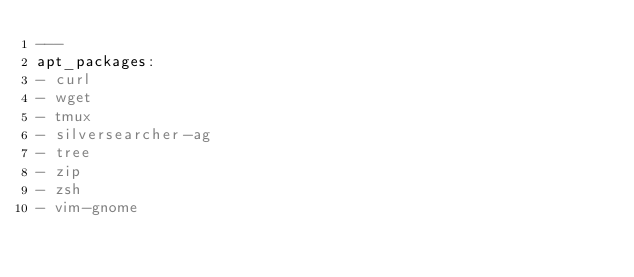Convert code to text. <code><loc_0><loc_0><loc_500><loc_500><_YAML_>---
apt_packages:
- curl
- wget
- tmux
- silversearcher-ag
- tree
- zip
- zsh
- vim-gnome
</code> 